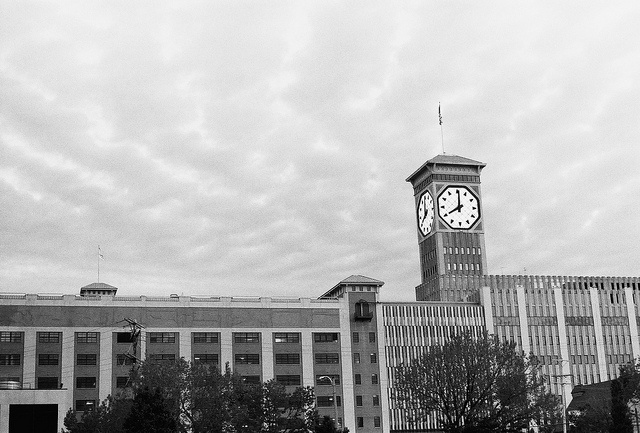Describe the objects in this image and their specific colors. I can see clock in lightgray, white, black, darkgray, and gray tones and clock in lightgray, white, gray, darkgray, and black tones in this image. 